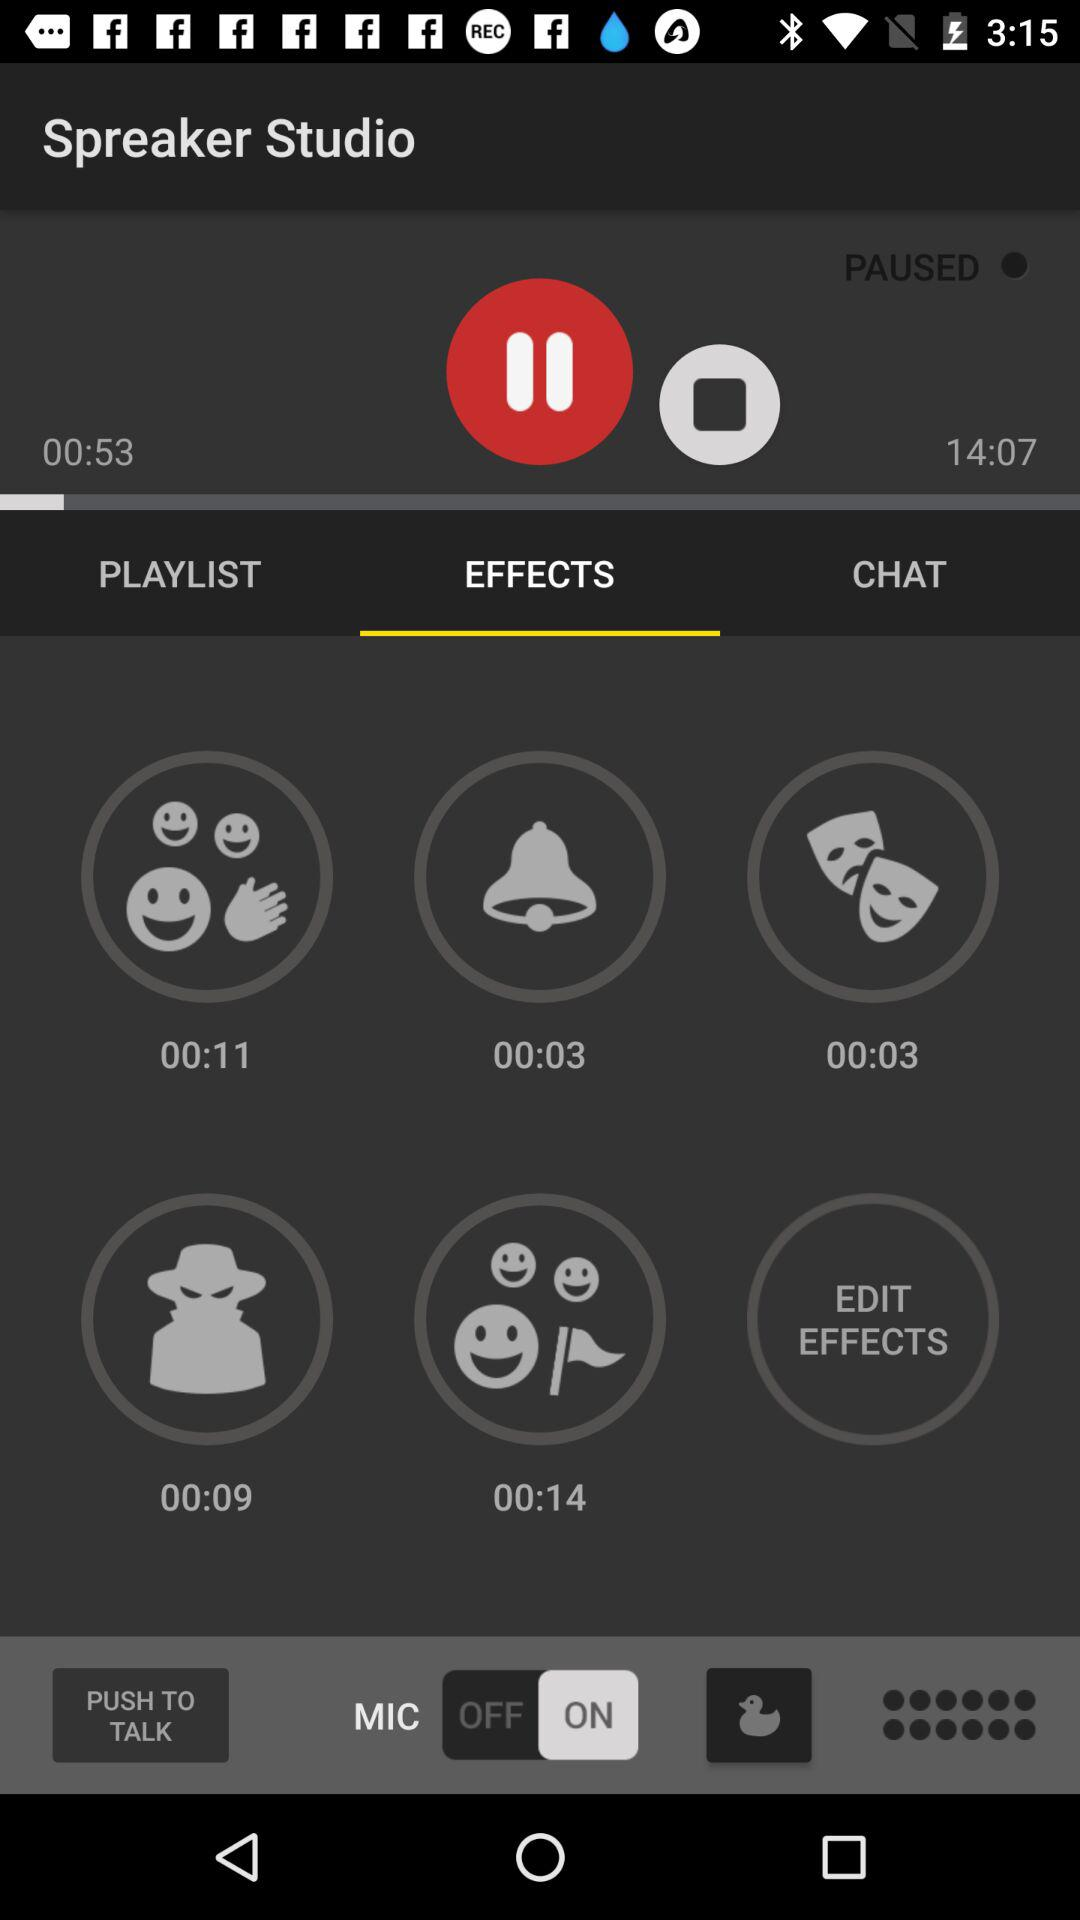What is the status of "MIC"? The status is "on". 